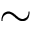<formula> <loc_0><loc_0><loc_500><loc_500>\sim</formula> 